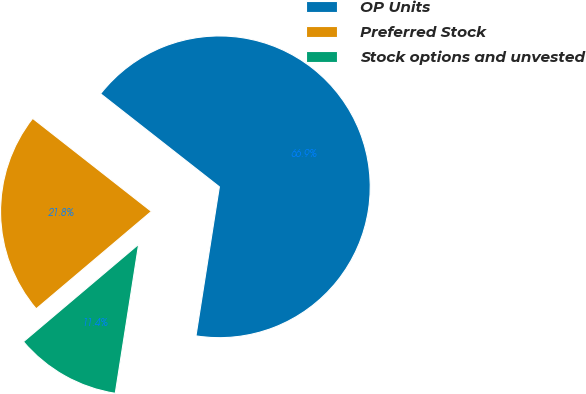Convert chart to OTSL. <chart><loc_0><loc_0><loc_500><loc_500><pie_chart><fcel>OP Units<fcel>Preferred Stock<fcel>Stock options and unvested<nl><fcel>66.9%<fcel>21.75%<fcel>11.35%<nl></chart> 